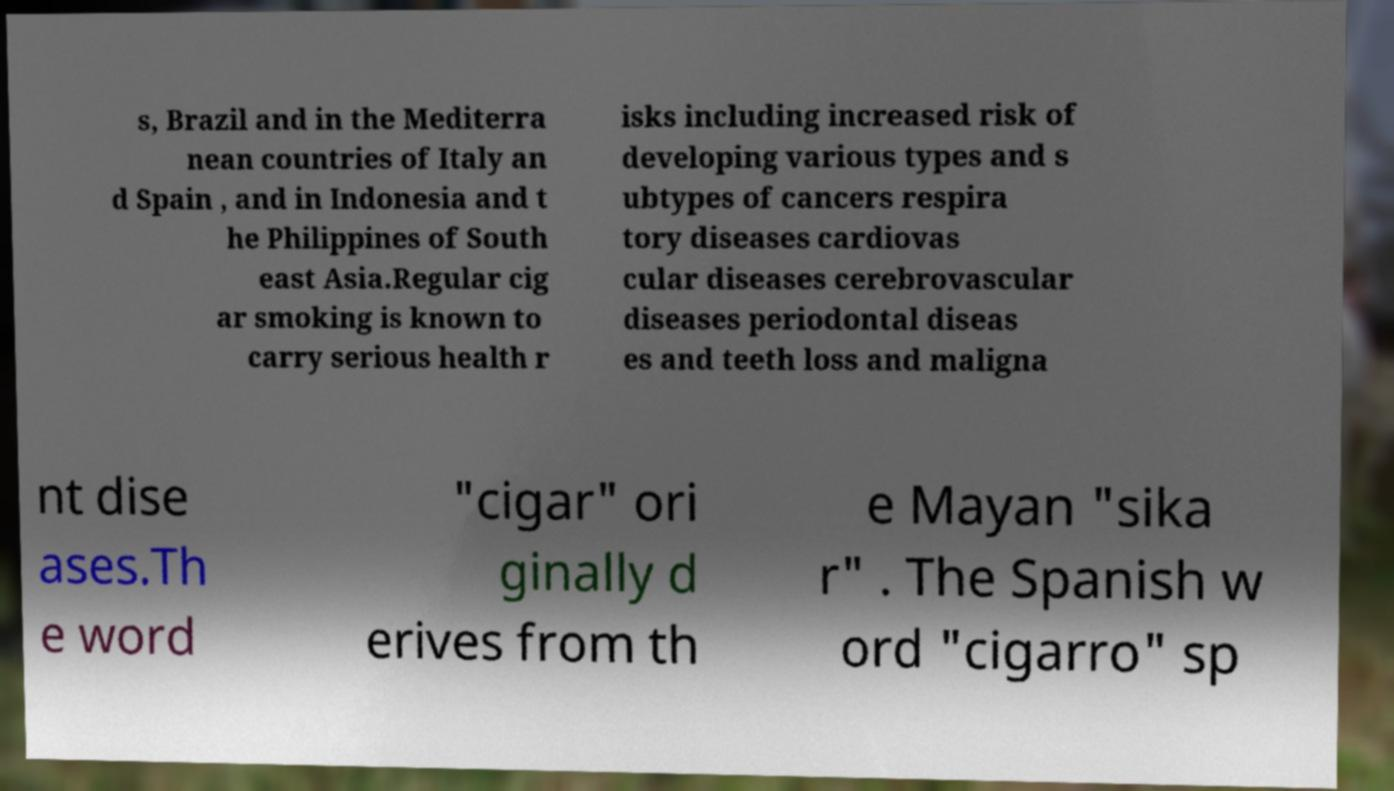Please identify and transcribe the text found in this image. s, Brazil and in the Mediterra nean countries of Italy an d Spain , and in Indonesia and t he Philippines of South east Asia.Regular cig ar smoking is known to carry serious health r isks including increased risk of developing various types and s ubtypes of cancers respira tory diseases cardiovas cular diseases cerebrovascular diseases periodontal diseas es and teeth loss and maligna nt dise ases.Th e word "cigar" ori ginally d erives from th e Mayan "sika r" . The Spanish w ord "cigarro" sp 